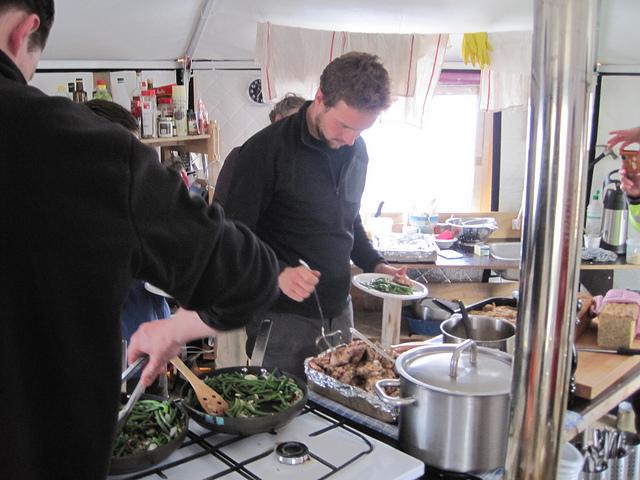What are the people looking at?
Keep it brief. Food. Is it day or night time outside?
Keep it brief. Day. What color is the top of the lid of the fourth bottle from the left?
Quick response, please. Red. Could the food be Asian?
Concise answer only. Yes. How many yellow rubber gloves are in the picture?
Quick response, please. 2. Who is using these pan?
Keep it brief. Person. What vegetable is the man cutting?
Answer briefly. Green beans. What is in the big bowl on the left?
Give a very brief answer. Green beans. 